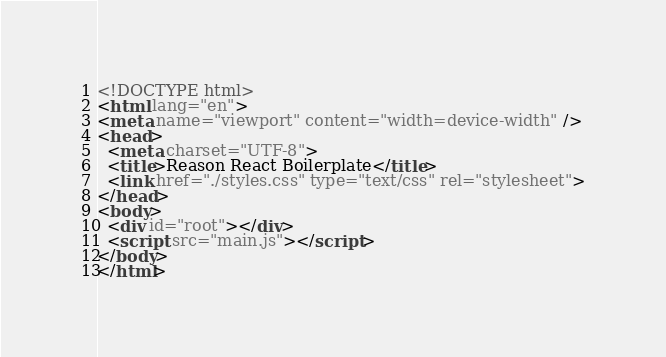<code> <loc_0><loc_0><loc_500><loc_500><_HTML_><!DOCTYPE html>
<html lang="en">
<meta name="viewport" content="width=device-width" />
<head>
  <meta charset="UTF-8">
  <title>Reason React Boilerplate</title>
  <link href="./styles.css" type="text/css" rel="stylesheet">
</head>
<body>
  <div id="root"></div>
  <script src="main.js"></script>
</body>
</html>
</code> 